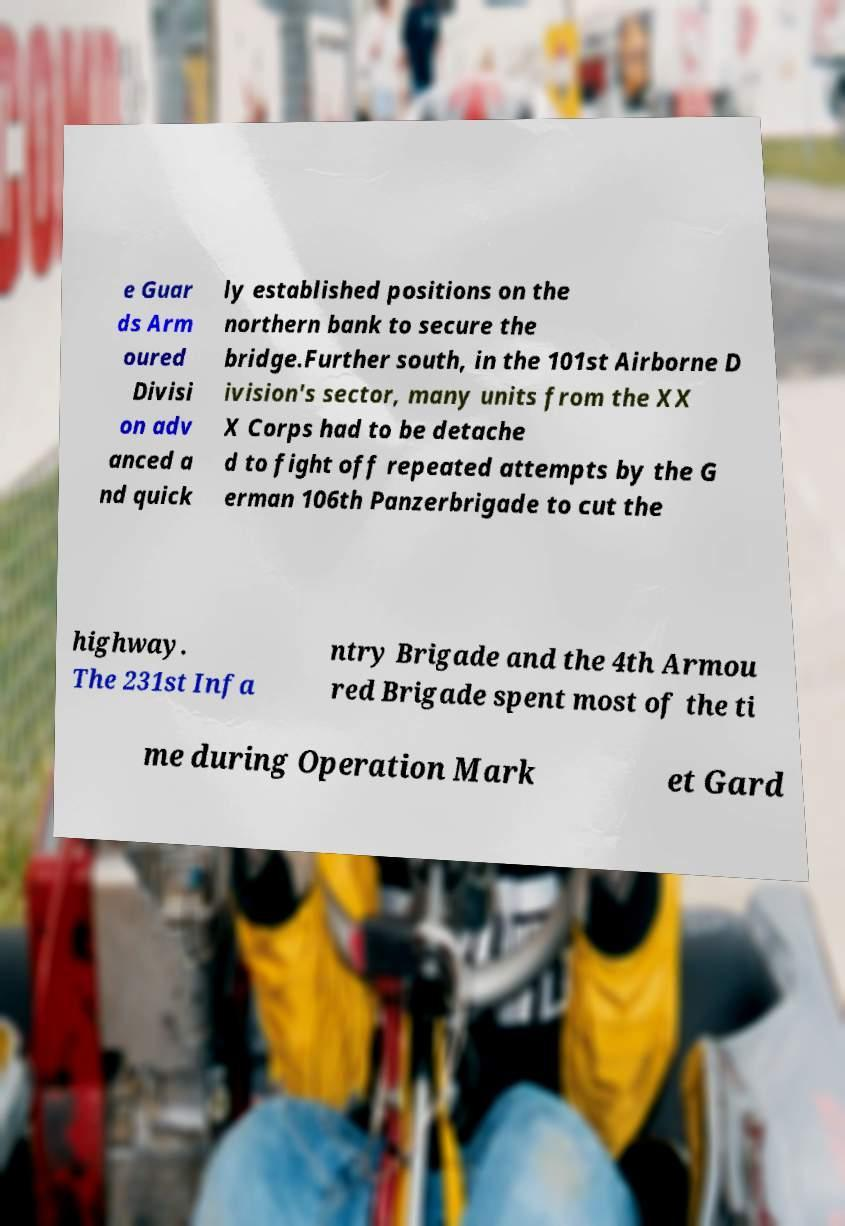Can you read and provide the text displayed in the image?This photo seems to have some interesting text. Can you extract and type it out for me? e Guar ds Arm oured Divisi on adv anced a nd quick ly established positions on the northern bank to secure the bridge.Further south, in the 101st Airborne D ivision's sector, many units from the XX X Corps had to be detache d to fight off repeated attempts by the G erman 106th Panzerbrigade to cut the highway. The 231st Infa ntry Brigade and the 4th Armou red Brigade spent most of the ti me during Operation Mark et Gard 